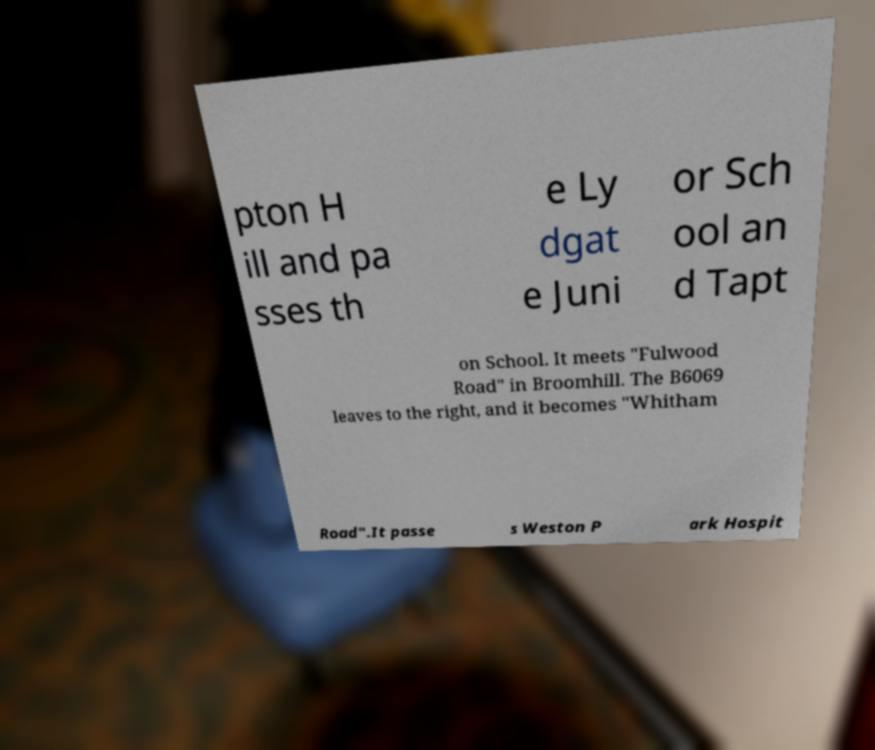Please read and relay the text visible in this image. What does it say? pton H ill and pa sses th e Ly dgat e Juni or Sch ool an d Tapt on School. It meets "Fulwood Road" in Broomhill. The B6069 leaves to the right, and it becomes "Whitham Road".It passe s Weston P ark Hospit 